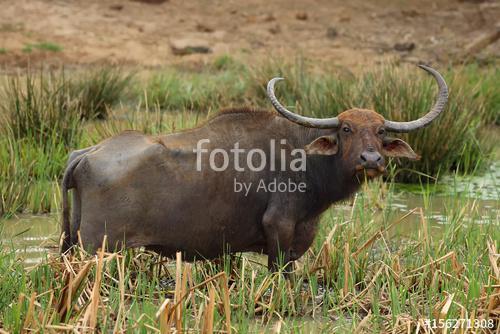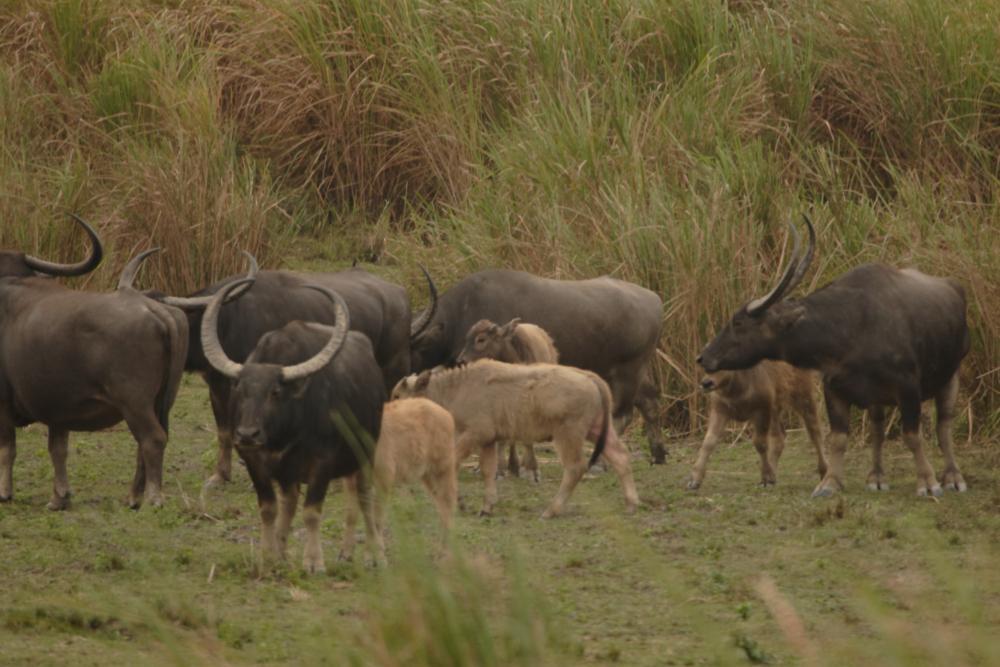The first image is the image on the left, the second image is the image on the right. Given the left and right images, does the statement "At least 2 cows are standing in the water." hold true? Answer yes or no. No. The first image is the image on the left, the second image is the image on the right. Evaluate the accuracy of this statement regarding the images: "The right image contains exactly one water buffalo.". Is it true? Answer yes or no. No. 